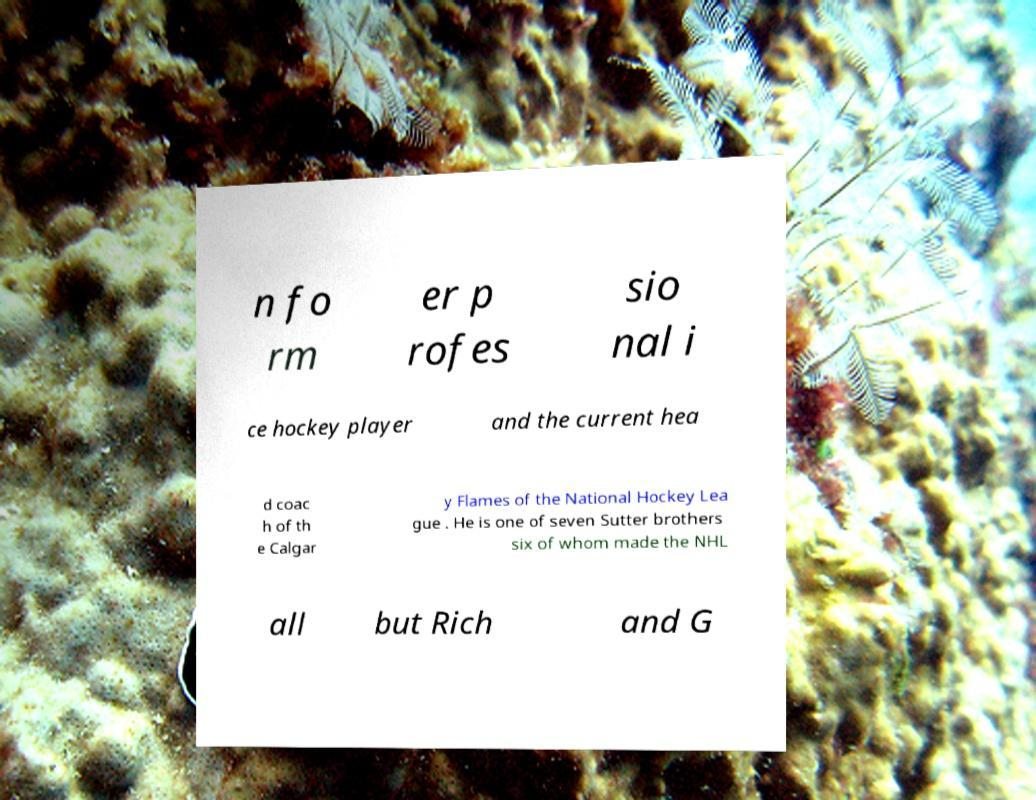Please read and relay the text visible in this image. What does it say? n fo rm er p rofes sio nal i ce hockey player and the current hea d coac h of th e Calgar y Flames of the National Hockey Lea gue . He is one of seven Sutter brothers six of whom made the NHL all but Rich and G 